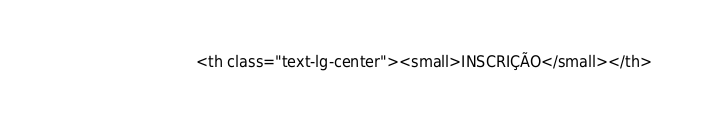Convert code to text. <code><loc_0><loc_0><loc_500><loc_500><_PHP_>                            <th class="text-lg-center"><small>INSCRIÇÃO</small></th></code> 